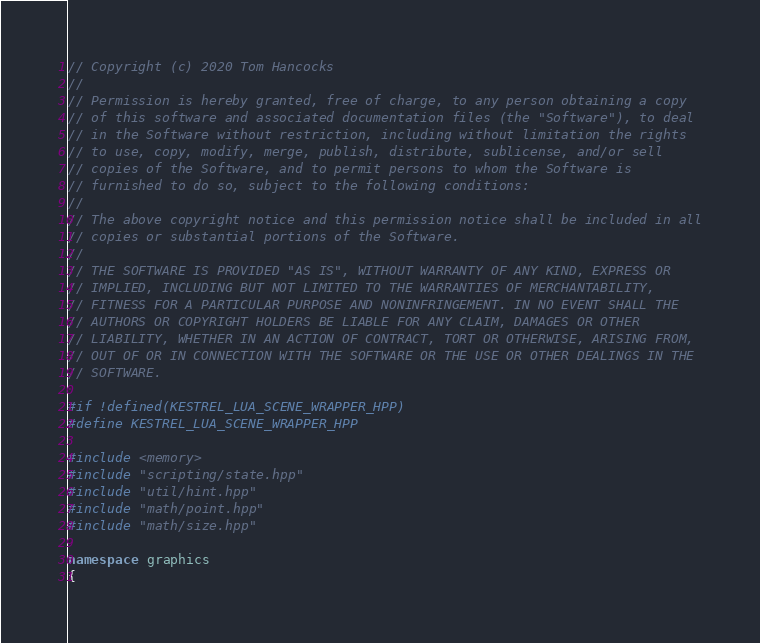<code> <loc_0><loc_0><loc_500><loc_500><_C++_>// Copyright (c) 2020 Tom Hancocks
//
// Permission is hereby granted, free of charge, to any person obtaining a copy
// of this software and associated documentation files (the "Software"), to deal
// in the Software without restriction, including without limitation the rights
// to use, copy, modify, merge, publish, distribute, sublicense, and/or sell
// copies of the Software, and to permit persons to whom the Software is
// furnished to do so, subject to the following conditions:
//
// The above copyright notice and this permission notice shall be included in all
// copies or substantial portions of the Software.
//
// THE SOFTWARE IS PROVIDED "AS IS", WITHOUT WARRANTY OF ANY KIND, EXPRESS OR
// IMPLIED, INCLUDING BUT NOT LIMITED TO THE WARRANTIES OF MERCHANTABILITY,
// FITNESS FOR A PARTICULAR PURPOSE AND NONINFRINGEMENT. IN NO EVENT SHALL THE
// AUTHORS OR COPYRIGHT HOLDERS BE LIABLE FOR ANY CLAIM, DAMAGES OR OTHER
// LIABILITY, WHETHER IN AN ACTION OF CONTRACT, TORT OR OTHERWISE, ARISING FROM,
// OUT OF OR IN CONNECTION WITH THE SOFTWARE OR THE USE OR OTHER DEALINGS IN THE
// SOFTWARE.

#if !defined(KESTREL_LUA_SCENE_WRAPPER_HPP)
#define KESTREL_LUA_SCENE_WRAPPER_HPP

#include <memory>
#include "scripting/state.hpp"
#include "util/hint.hpp"
#include "math/point.hpp"
#include "math/size.hpp"

namespace graphics
{
</code> 